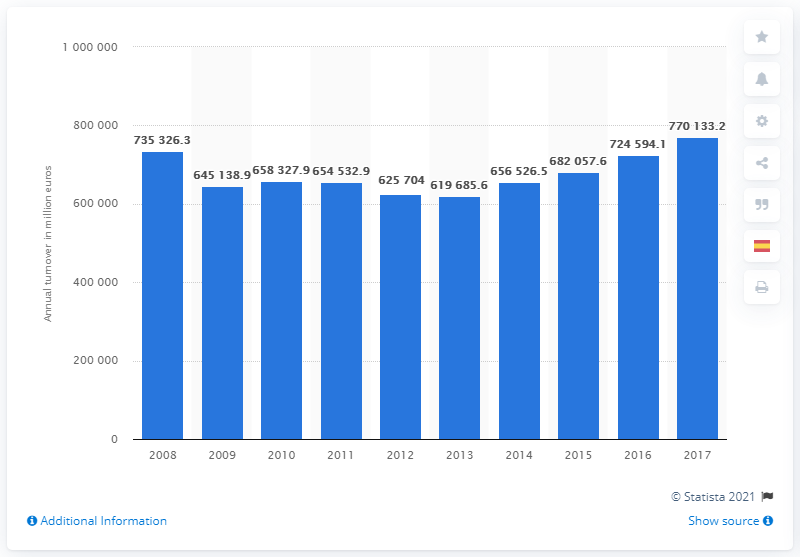Point out several critical features in this image. In 2017, the turnover of the wholesale and retail trade industry was 770,133.2. 